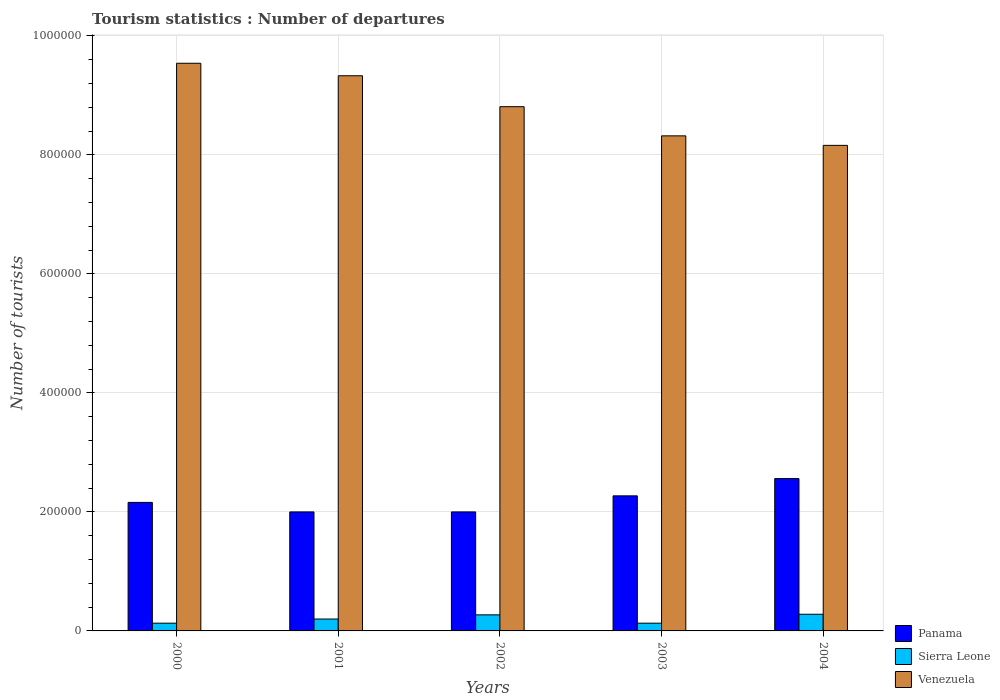How many different coloured bars are there?
Your answer should be very brief. 3. Are the number of bars per tick equal to the number of legend labels?
Keep it short and to the point. Yes. Are the number of bars on each tick of the X-axis equal?
Keep it short and to the point. Yes. What is the number of tourist departures in Panama in 2002?
Your response must be concise. 2.00e+05. Across all years, what is the maximum number of tourist departures in Venezuela?
Give a very brief answer. 9.54e+05. Across all years, what is the minimum number of tourist departures in Sierra Leone?
Ensure brevity in your answer.  1.30e+04. In which year was the number of tourist departures in Sierra Leone maximum?
Provide a succinct answer. 2004. In which year was the number of tourist departures in Venezuela minimum?
Offer a very short reply. 2004. What is the total number of tourist departures in Sierra Leone in the graph?
Offer a terse response. 1.01e+05. What is the difference between the number of tourist departures in Sierra Leone in 2001 and that in 2002?
Your answer should be very brief. -7000. What is the difference between the number of tourist departures in Venezuela in 2003 and the number of tourist departures in Sierra Leone in 2004?
Offer a terse response. 8.04e+05. What is the average number of tourist departures in Panama per year?
Provide a succinct answer. 2.20e+05. In the year 2001, what is the difference between the number of tourist departures in Sierra Leone and number of tourist departures in Panama?
Offer a very short reply. -1.80e+05. What is the ratio of the number of tourist departures in Sierra Leone in 2001 to that in 2003?
Make the answer very short. 1.54. Is the number of tourist departures in Panama in 2000 less than that in 2001?
Make the answer very short. No. What is the difference between the highest and the second highest number of tourist departures in Venezuela?
Your response must be concise. 2.10e+04. What is the difference between the highest and the lowest number of tourist departures in Panama?
Keep it short and to the point. 5.60e+04. Is the sum of the number of tourist departures in Venezuela in 2002 and 2003 greater than the maximum number of tourist departures in Panama across all years?
Provide a short and direct response. Yes. What does the 3rd bar from the left in 2003 represents?
Your response must be concise. Venezuela. What does the 3rd bar from the right in 2003 represents?
Provide a succinct answer. Panama. Is it the case that in every year, the sum of the number of tourist departures in Panama and number of tourist departures in Venezuela is greater than the number of tourist departures in Sierra Leone?
Provide a succinct answer. Yes. How many years are there in the graph?
Ensure brevity in your answer.  5. What is the difference between two consecutive major ticks on the Y-axis?
Your response must be concise. 2.00e+05. Are the values on the major ticks of Y-axis written in scientific E-notation?
Offer a very short reply. No. Does the graph contain any zero values?
Offer a terse response. No. Does the graph contain grids?
Ensure brevity in your answer.  Yes. How many legend labels are there?
Provide a short and direct response. 3. How are the legend labels stacked?
Provide a succinct answer. Vertical. What is the title of the graph?
Your answer should be very brief. Tourism statistics : Number of departures. Does "Paraguay" appear as one of the legend labels in the graph?
Your answer should be compact. No. What is the label or title of the X-axis?
Your answer should be very brief. Years. What is the label or title of the Y-axis?
Your answer should be very brief. Number of tourists. What is the Number of tourists of Panama in 2000?
Ensure brevity in your answer.  2.16e+05. What is the Number of tourists of Sierra Leone in 2000?
Keep it short and to the point. 1.30e+04. What is the Number of tourists of Venezuela in 2000?
Your answer should be compact. 9.54e+05. What is the Number of tourists in Panama in 2001?
Your response must be concise. 2.00e+05. What is the Number of tourists of Sierra Leone in 2001?
Keep it short and to the point. 2.00e+04. What is the Number of tourists in Venezuela in 2001?
Provide a succinct answer. 9.33e+05. What is the Number of tourists of Panama in 2002?
Provide a short and direct response. 2.00e+05. What is the Number of tourists in Sierra Leone in 2002?
Your response must be concise. 2.70e+04. What is the Number of tourists of Venezuela in 2002?
Your answer should be very brief. 8.81e+05. What is the Number of tourists in Panama in 2003?
Keep it short and to the point. 2.27e+05. What is the Number of tourists of Sierra Leone in 2003?
Provide a short and direct response. 1.30e+04. What is the Number of tourists in Venezuela in 2003?
Offer a terse response. 8.32e+05. What is the Number of tourists of Panama in 2004?
Give a very brief answer. 2.56e+05. What is the Number of tourists of Sierra Leone in 2004?
Ensure brevity in your answer.  2.80e+04. What is the Number of tourists of Venezuela in 2004?
Keep it short and to the point. 8.16e+05. Across all years, what is the maximum Number of tourists in Panama?
Your answer should be compact. 2.56e+05. Across all years, what is the maximum Number of tourists of Sierra Leone?
Your response must be concise. 2.80e+04. Across all years, what is the maximum Number of tourists of Venezuela?
Give a very brief answer. 9.54e+05. Across all years, what is the minimum Number of tourists in Panama?
Provide a short and direct response. 2.00e+05. Across all years, what is the minimum Number of tourists in Sierra Leone?
Make the answer very short. 1.30e+04. Across all years, what is the minimum Number of tourists of Venezuela?
Make the answer very short. 8.16e+05. What is the total Number of tourists in Panama in the graph?
Provide a short and direct response. 1.10e+06. What is the total Number of tourists in Sierra Leone in the graph?
Make the answer very short. 1.01e+05. What is the total Number of tourists of Venezuela in the graph?
Ensure brevity in your answer.  4.42e+06. What is the difference between the Number of tourists in Panama in 2000 and that in 2001?
Keep it short and to the point. 1.60e+04. What is the difference between the Number of tourists in Sierra Leone in 2000 and that in 2001?
Ensure brevity in your answer.  -7000. What is the difference between the Number of tourists of Venezuela in 2000 and that in 2001?
Offer a terse response. 2.10e+04. What is the difference between the Number of tourists of Panama in 2000 and that in 2002?
Provide a short and direct response. 1.60e+04. What is the difference between the Number of tourists of Sierra Leone in 2000 and that in 2002?
Offer a very short reply. -1.40e+04. What is the difference between the Number of tourists in Venezuela in 2000 and that in 2002?
Make the answer very short. 7.30e+04. What is the difference between the Number of tourists of Panama in 2000 and that in 2003?
Give a very brief answer. -1.10e+04. What is the difference between the Number of tourists in Venezuela in 2000 and that in 2003?
Your response must be concise. 1.22e+05. What is the difference between the Number of tourists in Panama in 2000 and that in 2004?
Your answer should be very brief. -4.00e+04. What is the difference between the Number of tourists of Sierra Leone in 2000 and that in 2004?
Provide a succinct answer. -1.50e+04. What is the difference between the Number of tourists of Venezuela in 2000 and that in 2004?
Your response must be concise. 1.38e+05. What is the difference between the Number of tourists in Sierra Leone in 2001 and that in 2002?
Your answer should be very brief. -7000. What is the difference between the Number of tourists in Venezuela in 2001 and that in 2002?
Ensure brevity in your answer.  5.20e+04. What is the difference between the Number of tourists of Panama in 2001 and that in 2003?
Provide a short and direct response. -2.70e+04. What is the difference between the Number of tourists in Sierra Leone in 2001 and that in 2003?
Your response must be concise. 7000. What is the difference between the Number of tourists of Venezuela in 2001 and that in 2003?
Make the answer very short. 1.01e+05. What is the difference between the Number of tourists of Panama in 2001 and that in 2004?
Your answer should be compact. -5.60e+04. What is the difference between the Number of tourists of Sierra Leone in 2001 and that in 2004?
Make the answer very short. -8000. What is the difference between the Number of tourists in Venezuela in 2001 and that in 2004?
Make the answer very short. 1.17e+05. What is the difference between the Number of tourists in Panama in 2002 and that in 2003?
Give a very brief answer. -2.70e+04. What is the difference between the Number of tourists of Sierra Leone in 2002 and that in 2003?
Offer a very short reply. 1.40e+04. What is the difference between the Number of tourists in Venezuela in 2002 and that in 2003?
Your response must be concise. 4.90e+04. What is the difference between the Number of tourists of Panama in 2002 and that in 2004?
Provide a succinct answer. -5.60e+04. What is the difference between the Number of tourists of Sierra Leone in 2002 and that in 2004?
Your answer should be compact. -1000. What is the difference between the Number of tourists of Venezuela in 2002 and that in 2004?
Your answer should be compact. 6.50e+04. What is the difference between the Number of tourists in Panama in 2003 and that in 2004?
Give a very brief answer. -2.90e+04. What is the difference between the Number of tourists of Sierra Leone in 2003 and that in 2004?
Your response must be concise. -1.50e+04. What is the difference between the Number of tourists in Venezuela in 2003 and that in 2004?
Give a very brief answer. 1.60e+04. What is the difference between the Number of tourists of Panama in 2000 and the Number of tourists of Sierra Leone in 2001?
Ensure brevity in your answer.  1.96e+05. What is the difference between the Number of tourists in Panama in 2000 and the Number of tourists in Venezuela in 2001?
Provide a short and direct response. -7.17e+05. What is the difference between the Number of tourists of Sierra Leone in 2000 and the Number of tourists of Venezuela in 2001?
Keep it short and to the point. -9.20e+05. What is the difference between the Number of tourists in Panama in 2000 and the Number of tourists in Sierra Leone in 2002?
Provide a short and direct response. 1.89e+05. What is the difference between the Number of tourists in Panama in 2000 and the Number of tourists in Venezuela in 2002?
Make the answer very short. -6.65e+05. What is the difference between the Number of tourists in Sierra Leone in 2000 and the Number of tourists in Venezuela in 2002?
Offer a terse response. -8.68e+05. What is the difference between the Number of tourists in Panama in 2000 and the Number of tourists in Sierra Leone in 2003?
Offer a terse response. 2.03e+05. What is the difference between the Number of tourists in Panama in 2000 and the Number of tourists in Venezuela in 2003?
Provide a succinct answer. -6.16e+05. What is the difference between the Number of tourists of Sierra Leone in 2000 and the Number of tourists of Venezuela in 2003?
Provide a short and direct response. -8.19e+05. What is the difference between the Number of tourists in Panama in 2000 and the Number of tourists in Sierra Leone in 2004?
Your answer should be very brief. 1.88e+05. What is the difference between the Number of tourists of Panama in 2000 and the Number of tourists of Venezuela in 2004?
Offer a very short reply. -6.00e+05. What is the difference between the Number of tourists of Sierra Leone in 2000 and the Number of tourists of Venezuela in 2004?
Provide a succinct answer. -8.03e+05. What is the difference between the Number of tourists of Panama in 2001 and the Number of tourists of Sierra Leone in 2002?
Keep it short and to the point. 1.73e+05. What is the difference between the Number of tourists in Panama in 2001 and the Number of tourists in Venezuela in 2002?
Offer a very short reply. -6.81e+05. What is the difference between the Number of tourists of Sierra Leone in 2001 and the Number of tourists of Venezuela in 2002?
Keep it short and to the point. -8.61e+05. What is the difference between the Number of tourists of Panama in 2001 and the Number of tourists of Sierra Leone in 2003?
Offer a very short reply. 1.87e+05. What is the difference between the Number of tourists of Panama in 2001 and the Number of tourists of Venezuela in 2003?
Your answer should be very brief. -6.32e+05. What is the difference between the Number of tourists of Sierra Leone in 2001 and the Number of tourists of Venezuela in 2003?
Give a very brief answer. -8.12e+05. What is the difference between the Number of tourists of Panama in 2001 and the Number of tourists of Sierra Leone in 2004?
Provide a short and direct response. 1.72e+05. What is the difference between the Number of tourists in Panama in 2001 and the Number of tourists in Venezuela in 2004?
Make the answer very short. -6.16e+05. What is the difference between the Number of tourists of Sierra Leone in 2001 and the Number of tourists of Venezuela in 2004?
Ensure brevity in your answer.  -7.96e+05. What is the difference between the Number of tourists in Panama in 2002 and the Number of tourists in Sierra Leone in 2003?
Offer a very short reply. 1.87e+05. What is the difference between the Number of tourists in Panama in 2002 and the Number of tourists in Venezuela in 2003?
Make the answer very short. -6.32e+05. What is the difference between the Number of tourists of Sierra Leone in 2002 and the Number of tourists of Venezuela in 2003?
Your answer should be very brief. -8.05e+05. What is the difference between the Number of tourists in Panama in 2002 and the Number of tourists in Sierra Leone in 2004?
Your answer should be compact. 1.72e+05. What is the difference between the Number of tourists in Panama in 2002 and the Number of tourists in Venezuela in 2004?
Offer a very short reply. -6.16e+05. What is the difference between the Number of tourists in Sierra Leone in 2002 and the Number of tourists in Venezuela in 2004?
Provide a short and direct response. -7.89e+05. What is the difference between the Number of tourists in Panama in 2003 and the Number of tourists in Sierra Leone in 2004?
Give a very brief answer. 1.99e+05. What is the difference between the Number of tourists of Panama in 2003 and the Number of tourists of Venezuela in 2004?
Give a very brief answer. -5.89e+05. What is the difference between the Number of tourists of Sierra Leone in 2003 and the Number of tourists of Venezuela in 2004?
Your response must be concise. -8.03e+05. What is the average Number of tourists of Panama per year?
Make the answer very short. 2.20e+05. What is the average Number of tourists in Sierra Leone per year?
Offer a very short reply. 2.02e+04. What is the average Number of tourists of Venezuela per year?
Your answer should be very brief. 8.83e+05. In the year 2000, what is the difference between the Number of tourists of Panama and Number of tourists of Sierra Leone?
Make the answer very short. 2.03e+05. In the year 2000, what is the difference between the Number of tourists in Panama and Number of tourists in Venezuela?
Your response must be concise. -7.38e+05. In the year 2000, what is the difference between the Number of tourists of Sierra Leone and Number of tourists of Venezuela?
Your answer should be compact. -9.41e+05. In the year 2001, what is the difference between the Number of tourists in Panama and Number of tourists in Venezuela?
Keep it short and to the point. -7.33e+05. In the year 2001, what is the difference between the Number of tourists of Sierra Leone and Number of tourists of Venezuela?
Keep it short and to the point. -9.13e+05. In the year 2002, what is the difference between the Number of tourists in Panama and Number of tourists in Sierra Leone?
Ensure brevity in your answer.  1.73e+05. In the year 2002, what is the difference between the Number of tourists of Panama and Number of tourists of Venezuela?
Your answer should be compact. -6.81e+05. In the year 2002, what is the difference between the Number of tourists of Sierra Leone and Number of tourists of Venezuela?
Keep it short and to the point. -8.54e+05. In the year 2003, what is the difference between the Number of tourists of Panama and Number of tourists of Sierra Leone?
Offer a terse response. 2.14e+05. In the year 2003, what is the difference between the Number of tourists in Panama and Number of tourists in Venezuela?
Provide a short and direct response. -6.05e+05. In the year 2003, what is the difference between the Number of tourists of Sierra Leone and Number of tourists of Venezuela?
Make the answer very short. -8.19e+05. In the year 2004, what is the difference between the Number of tourists of Panama and Number of tourists of Sierra Leone?
Keep it short and to the point. 2.28e+05. In the year 2004, what is the difference between the Number of tourists in Panama and Number of tourists in Venezuela?
Provide a succinct answer. -5.60e+05. In the year 2004, what is the difference between the Number of tourists in Sierra Leone and Number of tourists in Venezuela?
Ensure brevity in your answer.  -7.88e+05. What is the ratio of the Number of tourists of Panama in 2000 to that in 2001?
Keep it short and to the point. 1.08. What is the ratio of the Number of tourists in Sierra Leone in 2000 to that in 2001?
Your answer should be compact. 0.65. What is the ratio of the Number of tourists in Venezuela in 2000 to that in 2001?
Make the answer very short. 1.02. What is the ratio of the Number of tourists in Sierra Leone in 2000 to that in 2002?
Your response must be concise. 0.48. What is the ratio of the Number of tourists in Venezuela in 2000 to that in 2002?
Your response must be concise. 1.08. What is the ratio of the Number of tourists in Panama in 2000 to that in 2003?
Make the answer very short. 0.95. What is the ratio of the Number of tourists in Sierra Leone in 2000 to that in 2003?
Make the answer very short. 1. What is the ratio of the Number of tourists of Venezuela in 2000 to that in 2003?
Ensure brevity in your answer.  1.15. What is the ratio of the Number of tourists in Panama in 2000 to that in 2004?
Your answer should be very brief. 0.84. What is the ratio of the Number of tourists of Sierra Leone in 2000 to that in 2004?
Ensure brevity in your answer.  0.46. What is the ratio of the Number of tourists of Venezuela in 2000 to that in 2004?
Your response must be concise. 1.17. What is the ratio of the Number of tourists of Sierra Leone in 2001 to that in 2002?
Offer a very short reply. 0.74. What is the ratio of the Number of tourists in Venezuela in 2001 to that in 2002?
Provide a succinct answer. 1.06. What is the ratio of the Number of tourists of Panama in 2001 to that in 2003?
Keep it short and to the point. 0.88. What is the ratio of the Number of tourists in Sierra Leone in 2001 to that in 2003?
Offer a very short reply. 1.54. What is the ratio of the Number of tourists of Venezuela in 2001 to that in 2003?
Keep it short and to the point. 1.12. What is the ratio of the Number of tourists in Panama in 2001 to that in 2004?
Give a very brief answer. 0.78. What is the ratio of the Number of tourists of Sierra Leone in 2001 to that in 2004?
Your answer should be very brief. 0.71. What is the ratio of the Number of tourists of Venezuela in 2001 to that in 2004?
Your answer should be compact. 1.14. What is the ratio of the Number of tourists of Panama in 2002 to that in 2003?
Your response must be concise. 0.88. What is the ratio of the Number of tourists of Sierra Leone in 2002 to that in 2003?
Ensure brevity in your answer.  2.08. What is the ratio of the Number of tourists of Venezuela in 2002 to that in 2003?
Keep it short and to the point. 1.06. What is the ratio of the Number of tourists of Panama in 2002 to that in 2004?
Your answer should be very brief. 0.78. What is the ratio of the Number of tourists in Venezuela in 2002 to that in 2004?
Give a very brief answer. 1.08. What is the ratio of the Number of tourists of Panama in 2003 to that in 2004?
Offer a very short reply. 0.89. What is the ratio of the Number of tourists in Sierra Leone in 2003 to that in 2004?
Keep it short and to the point. 0.46. What is the ratio of the Number of tourists of Venezuela in 2003 to that in 2004?
Your answer should be compact. 1.02. What is the difference between the highest and the second highest Number of tourists in Panama?
Your answer should be very brief. 2.90e+04. What is the difference between the highest and the second highest Number of tourists of Sierra Leone?
Provide a short and direct response. 1000. What is the difference between the highest and the second highest Number of tourists of Venezuela?
Provide a succinct answer. 2.10e+04. What is the difference between the highest and the lowest Number of tourists of Panama?
Give a very brief answer. 5.60e+04. What is the difference between the highest and the lowest Number of tourists of Sierra Leone?
Your answer should be compact. 1.50e+04. What is the difference between the highest and the lowest Number of tourists of Venezuela?
Your answer should be very brief. 1.38e+05. 